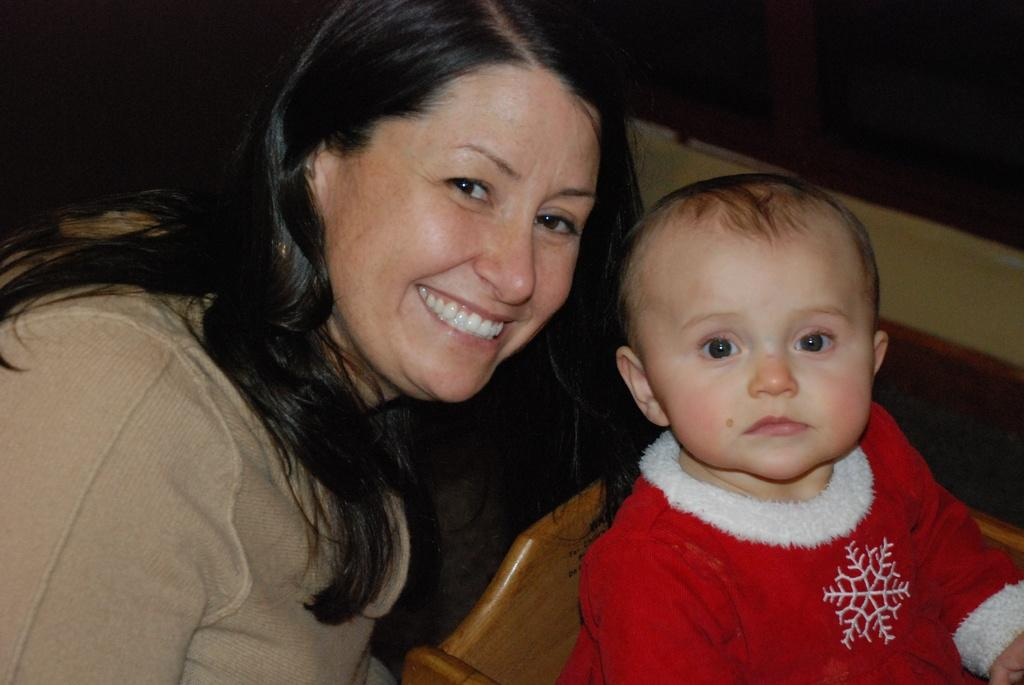Who is the main subject in the image? The main subject in the image is a woman. Can you describe the woman's expression? The woman is smiling in the image. What is the baby wearing in the image? The baby is wearing a red dress in the image. How would you describe the background of the image? The background of the image is dark. How many feet are visible in the image? There is no mention of feet in the image, so it is impossible to determine the number of feet visible. 